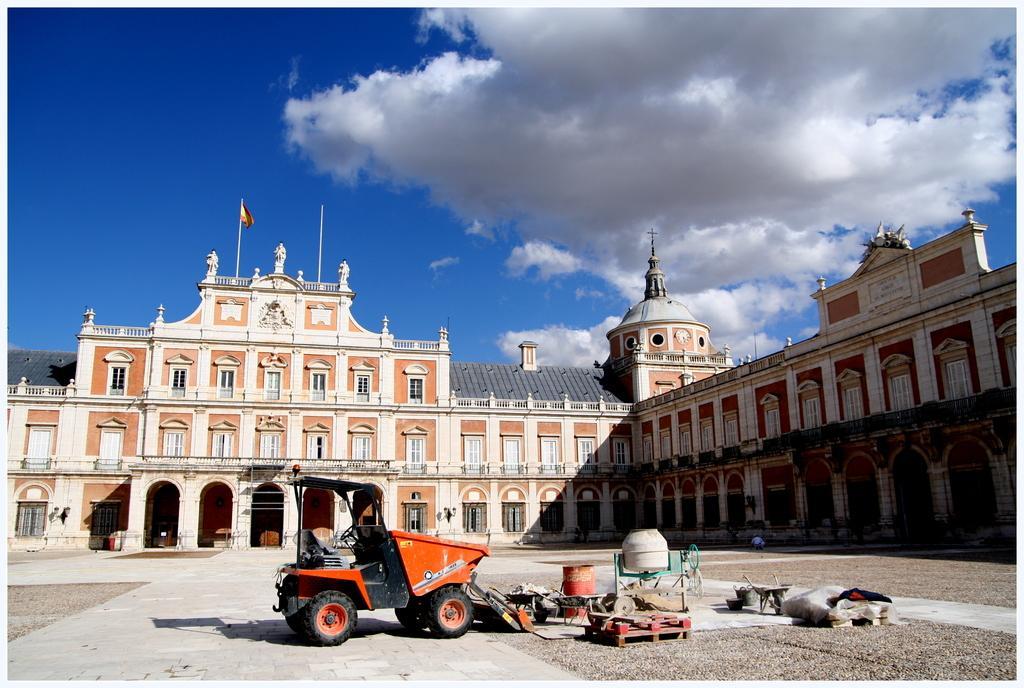Can you describe this image briefly? In the center of the picture there is a building. In the foreground of the picture there are vehicle and other construction material. Sky is sunny. 